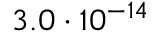<formula> <loc_0><loc_0><loc_500><loc_500>3 . 0 \cdot 1 0 ^ { - 1 4 }</formula> 